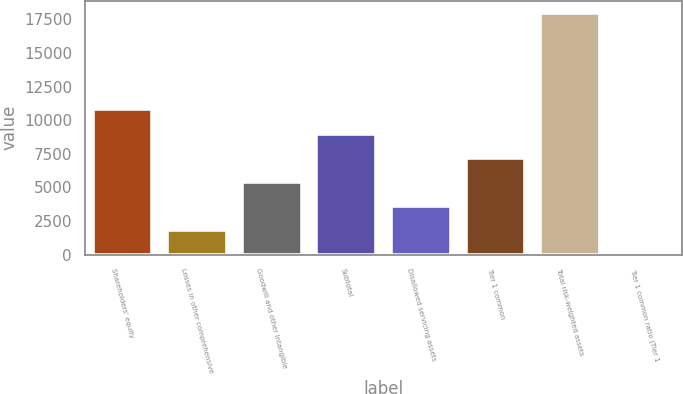Convert chart to OTSL. <chart><loc_0><loc_0><loc_500><loc_500><bar_chart><fcel>Shareholders' equity<fcel>Losses in other comprehensive<fcel>Goodwill and other intangible<fcel>Subtotal<fcel>Disallowed servicing assets<fcel>Tier 1 common<fcel>Total risk-weighted assets<fcel>Tier 1 common ratio (Tier 1<nl><fcel>10800.7<fcel>1811.61<fcel>5407.23<fcel>9002.85<fcel>3609.42<fcel>7205.04<fcel>17991.9<fcel>13.8<nl></chart> 